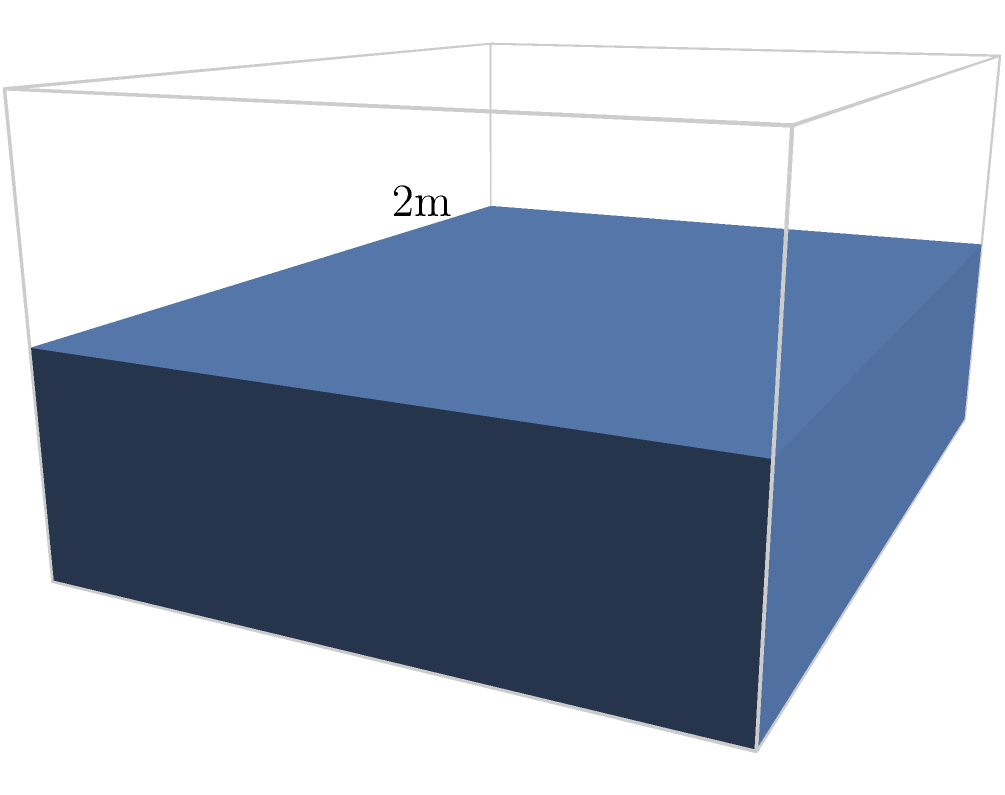A cargo hold measures 4m long, 3m wide, and 2m high. If cubic boxes with sides of 1m are to be stacked in this hold, what is the maximum number of boxes that can fit? To solve this problem, we need to follow these steps:

1) First, let's consider the dimensions of the cargo hold:
   Length (L) = 4m
   Width (W) = 3m
   Height (H) = 2m

2) Now, let's look at the dimensions of each box:
   Side length = 1m

3) We need to calculate how many boxes can fit in each dimension:
   - Along the length: $4 \div 1 = 4$ boxes
   - Along the width: $3 \div 1 = 3$ boxes
   - Along the height: $2 \div 1 = 2$ boxes

4) To get the total number of boxes, we multiply these numbers:
   $$ \text{Total boxes} = 4 \times 3 \times 2 = 24 $$

Therefore, the maximum number of 1m cubic boxes that can fit in the cargo hold is 24.
Answer: 24 boxes 